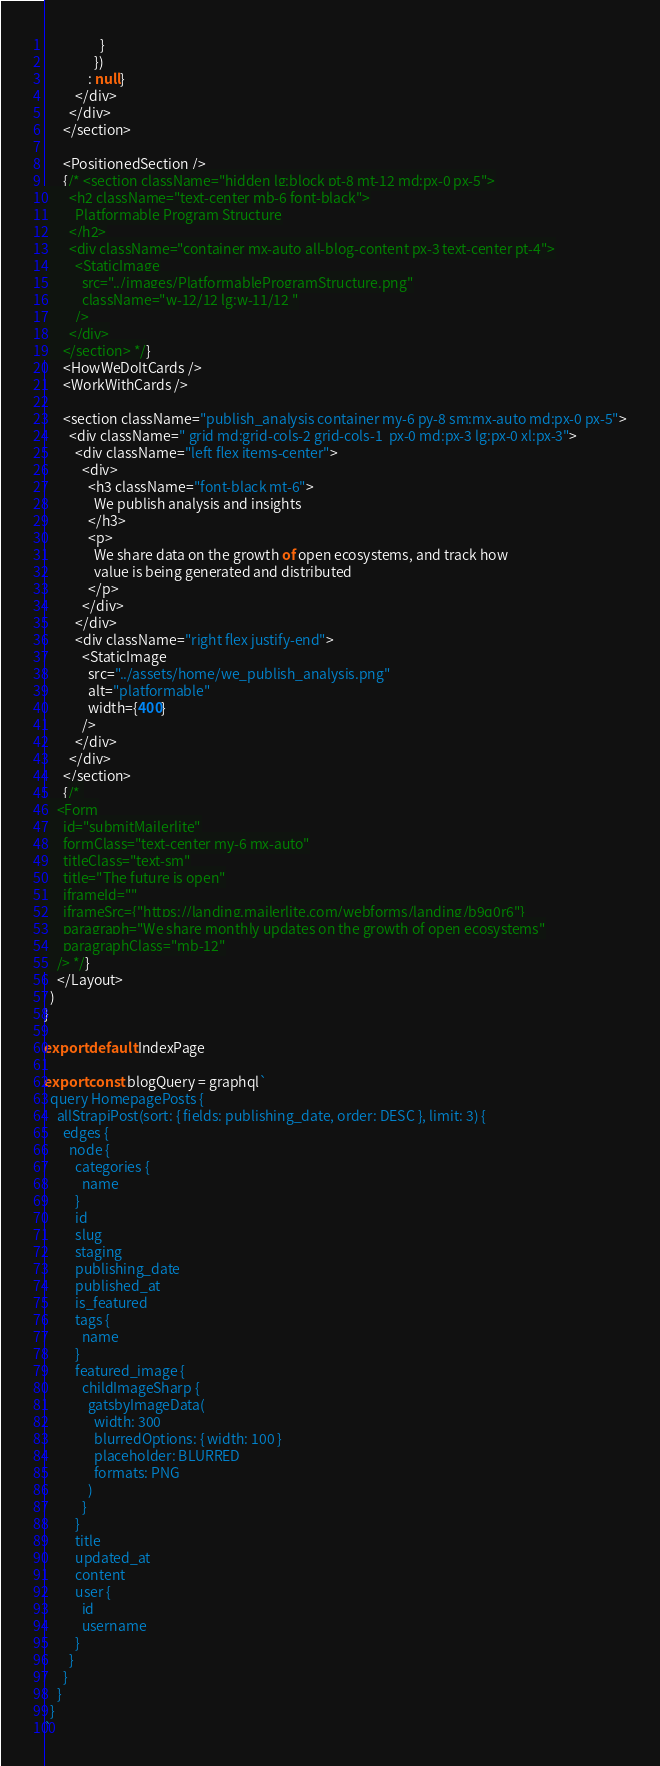<code> <loc_0><loc_0><loc_500><loc_500><_JavaScript_>                  }
                })
              : null}
          </div>
        </div>
      </section>

      <PositionedSection />
      {/* <section className="hidden lg:block pt-8 mt-12 md:px-0 px-5">
        <h2 className="text-center mb-6 font-black">
          Platformable Program Structure
        </h2>
        <div className="container mx-auto all-blog-content px-3 text-center pt-4">
          <StaticImage
            src="../images/PlatformableProgramStructure.png"
            className="w-12/12 lg:w-11/12 "
          />
        </div>
      </section> */}
      <HowWeDoItCards />
      <WorkWithCards />

      <section className="publish_analysis container my-6 py-8 sm:mx-auto md:px-0 px-5">
        <div className=" grid md:grid-cols-2 grid-cols-1  px-0 md:px-3 lg:px-0 xl:px-3">
          <div className="left flex items-center">
            <div>
              <h3 className="font-black mt-6">
                We publish analysis and insights
              </h3>
              <p>
                We share data on the growth of open ecosystems, and track how
                value is being generated and distributed
              </p>
            </div>
          </div>
          <div className="right flex justify-end">
            <StaticImage
              src="../assets/home/we_publish_analysis.png"
              alt="platformable"
              width={400}
            />
          </div>
        </div>
      </section>
      {/* 
    <Form
      id="submitMailerlite"
      formClass="text-center my-6 mx-auto"
      titleClass="text-sm"
      title="The future is open"
      iframeId=""
      iframeSrc={"https://landing.mailerlite.com/webforms/landing/b9q0r6"}
      paragraph="We share monthly updates on the growth of open ecosystems"
      paragraphClass="mb-12"
    /> */}
    </Layout>
  )
}

export default IndexPage

export const blogQuery = graphql`
  query HomepagePosts {
    allStrapiPost(sort: { fields: publishing_date, order: DESC }, limit: 3) {
      edges {
        node {
          categories {
            name
          }
          id
          slug
          staging
          publishing_date
          published_at
          is_featured
          tags {
            name
          }
          featured_image {
            childImageSharp {
              gatsbyImageData(
                width: 300
                blurredOptions: { width: 100 }
                placeholder: BLURRED
                formats: PNG
              )
            }
          }
          title
          updated_at
          content
          user {
            id
            username
          }
        }
      }
    }
  }
`
</code> 